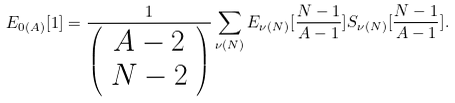<formula> <loc_0><loc_0><loc_500><loc_500>E _ { 0 ( A ) } [ 1 ] = \frac { 1 } { \left ( \begin{array} { c } A - 2 \\ N - 2 \end{array} \right ) } \sum _ { \nu ( N ) } E _ { \nu ( N ) } [ \frac { N - 1 } { A - 1 } ] S _ { \nu ( N ) } [ \frac { N - 1 } { A - 1 } ] .</formula> 